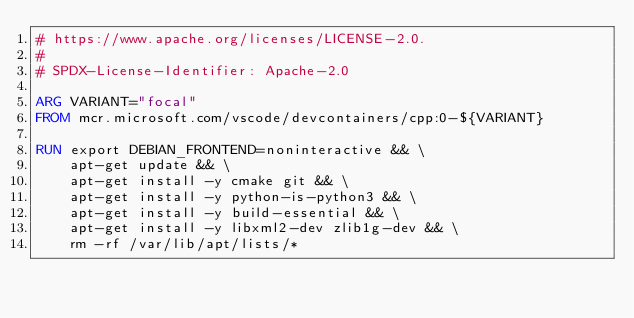<code> <loc_0><loc_0><loc_500><loc_500><_Dockerfile_># https://www.apache.org/licenses/LICENSE-2.0.
#
# SPDX-License-Identifier: Apache-2.0

ARG VARIANT="focal"
FROM mcr.microsoft.com/vscode/devcontainers/cpp:0-${VARIANT}

RUN export DEBIAN_FRONTEND=noninteractive && \
    apt-get update && \
    apt-get install -y cmake git && \
    apt-get install -y python-is-python3 && \
    apt-get install -y build-essential && \
    apt-get install -y libxml2-dev zlib1g-dev && \
    rm -rf /var/lib/apt/lists/*
</code> 